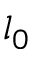<formula> <loc_0><loc_0><loc_500><loc_500>l _ { 0 }</formula> 